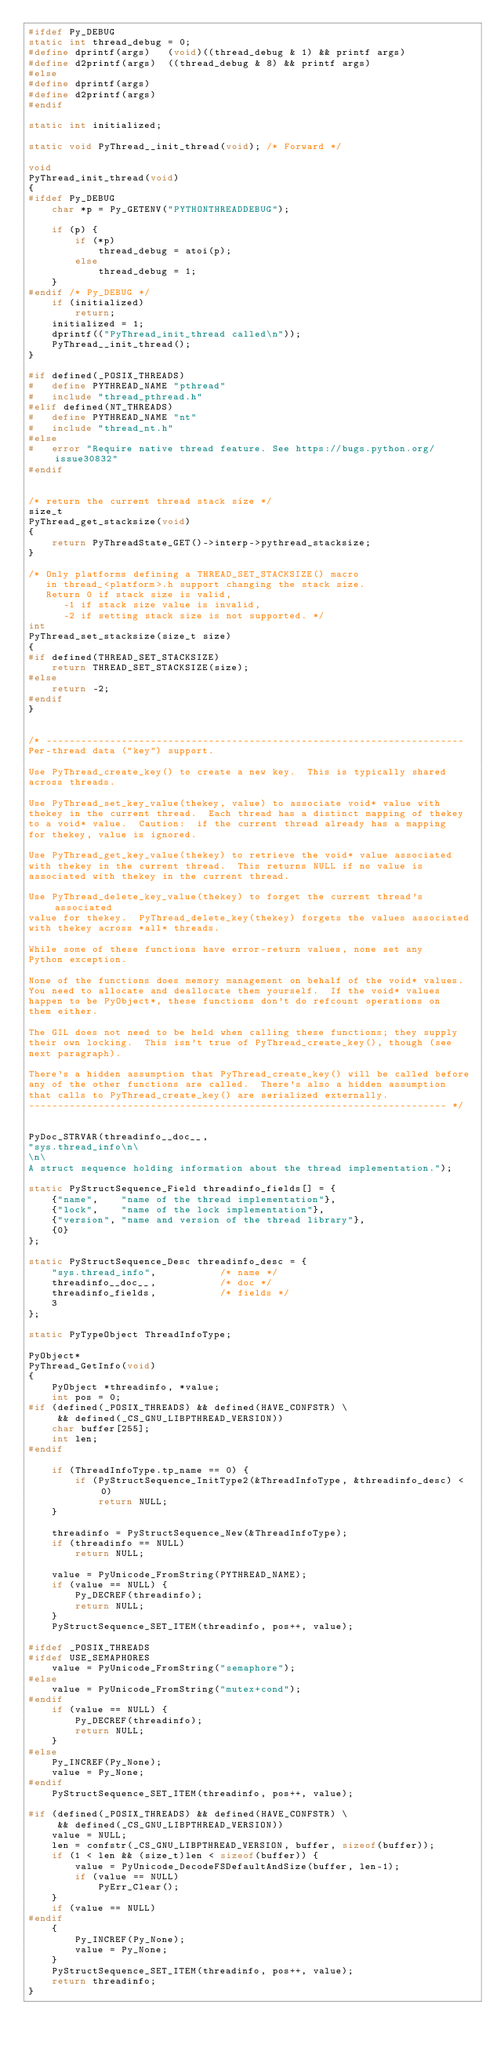<code> <loc_0><loc_0><loc_500><loc_500><_C_>#ifdef Py_DEBUG
static int thread_debug = 0;
#define dprintf(args)   (void)((thread_debug & 1) && printf args)
#define d2printf(args)  ((thread_debug & 8) && printf args)
#else
#define dprintf(args)
#define d2printf(args)
#endif

static int initialized;

static void PyThread__init_thread(void); /* Forward */

void
PyThread_init_thread(void)
{
#ifdef Py_DEBUG
    char *p = Py_GETENV("PYTHONTHREADDEBUG");

    if (p) {
        if (*p)
            thread_debug = atoi(p);
        else
            thread_debug = 1;
    }
#endif /* Py_DEBUG */
    if (initialized)
        return;
    initialized = 1;
    dprintf(("PyThread_init_thread called\n"));
    PyThread__init_thread();
}

#if defined(_POSIX_THREADS)
#   define PYTHREAD_NAME "pthread"
#   include "thread_pthread.h"
#elif defined(NT_THREADS)
#   define PYTHREAD_NAME "nt"
#   include "thread_nt.h"
#else
#   error "Require native thread feature. See https://bugs.python.org/issue30832"
#endif


/* return the current thread stack size */
size_t
PyThread_get_stacksize(void)
{
    return PyThreadState_GET()->interp->pythread_stacksize;
}

/* Only platforms defining a THREAD_SET_STACKSIZE() macro
   in thread_<platform>.h support changing the stack size.
   Return 0 if stack size is valid,
      -1 if stack size value is invalid,
      -2 if setting stack size is not supported. */
int
PyThread_set_stacksize(size_t size)
{
#if defined(THREAD_SET_STACKSIZE)
    return THREAD_SET_STACKSIZE(size);
#else
    return -2;
#endif
}


/* ------------------------------------------------------------------------
Per-thread data ("key") support.

Use PyThread_create_key() to create a new key.  This is typically shared
across threads.

Use PyThread_set_key_value(thekey, value) to associate void* value with
thekey in the current thread.  Each thread has a distinct mapping of thekey
to a void* value.  Caution:  if the current thread already has a mapping
for thekey, value is ignored.

Use PyThread_get_key_value(thekey) to retrieve the void* value associated
with thekey in the current thread.  This returns NULL if no value is
associated with thekey in the current thread.

Use PyThread_delete_key_value(thekey) to forget the current thread's associated
value for thekey.  PyThread_delete_key(thekey) forgets the values associated
with thekey across *all* threads.

While some of these functions have error-return values, none set any
Python exception.

None of the functions does memory management on behalf of the void* values.
You need to allocate and deallocate them yourself.  If the void* values
happen to be PyObject*, these functions don't do refcount operations on
them either.

The GIL does not need to be held when calling these functions; they supply
their own locking.  This isn't true of PyThread_create_key(), though (see
next paragraph).

There's a hidden assumption that PyThread_create_key() will be called before
any of the other functions are called.  There's also a hidden assumption
that calls to PyThread_create_key() are serialized externally.
------------------------------------------------------------------------ */


PyDoc_STRVAR(threadinfo__doc__,
"sys.thread_info\n\
\n\
A struct sequence holding information about the thread implementation.");

static PyStructSequence_Field threadinfo_fields[] = {
    {"name",    "name of the thread implementation"},
    {"lock",    "name of the lock implementation"},
    {"version", "name and version of the thread library"},
    {0}
};

static PyStructSequence_Desc threadinfo_desc = {
    "sys.thread_info",           /* name */
    threadinfo__doc__,           /* doc */
    threadinfo_fields,           /* fields */
    3
};

static PyTypeObject ThreadInfoType;

PyObject*
PyThread_GetInfo(void)
{
    PyObject *threadinfo, *value;
    int pos = 0;
#if (defined(_POSIX_THREADS) && defined(HAVE_CONFSTR) \
     && defined(_CS_GNU_LIBPTHREAD_VERSION))
    char buffer[255];
    int len;
#endif

    if (ThreadInfoType.tp_name == 0) {
        if (PyStructSequence_InitType2(&ThreadInfoType, &threadinfo_desc) < 0)
            return NULL;
    }

    threadinfo = PyStructSequence_New(&ThreadInfoType);
    if (threadinfo == NULL)
        return NULL;

    value = PyUnicode_FromString(PYTHREAD_NAME);
    if (value == NULL) {
        Py_DECREF(threadinfo);
        return NULL;
    }
    PyStructSequence_SET_ITEM(threadinfo, pos++, value);

#ifdef _POSIX_THREADS
#ifdef USE_SEMAPHORES
    value = PyUnicode_FromString("semaphore");
#else
    value = PyUnicode_FromString("mutex+cond");
#endif
    if (value == NULL) {
        Py_DECREF(threadinfo);
        return NULL;
    }
#else
    Py_INCREF(Py_None);
    value = Py_None;
#endif
    PyStructSequence_SET_ITEM(threadinfo, pos++, value);

#if (defined(_POSIX_THREADS) && defined(HAVE_CONFSTR) \
     && defined(_CS_GNU_LIBPTHREAD_VERSION))
    value = NULL;
    len = confstr(_CS_GNU_LIBPTHREAD_VERSION, buffer, sizeof(buffer));
    if (1 < len && (size_t)len < sizeof(buffer)) {
        value = PyUnicode_DecodeFSDefaultAndSize(buffer, len-1);
        if (value == NULL)
            PyErr_Clear();
    }
    if (value == NULL)
#endif
    {
        Py_INCREF(Py_None);
        value = Py_None;
    }
    PyStructSequence_SET_ITEM(threadinfo, pos++, value);
    return threadinfo;
}
</code> 